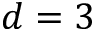Convert formula to latex. <formula><loc_0><loc_0><loc_500><loc_500>d = 3</formula> 